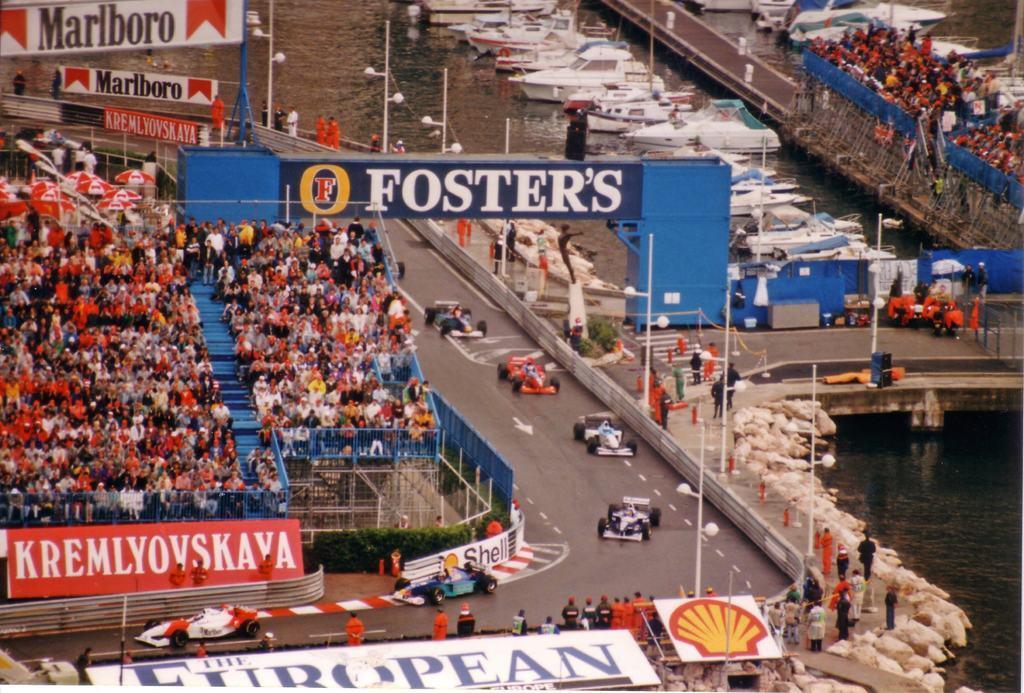In one or two sentences, can you explain what this image depicts? In this image there are a few racing cars on the track, to the left of the cars there are few spectators watching, to the right side of the cars there are a few people standing, beside them there are few boats on the water and there is a bridge, on the other side of the bridge there are few other people. 